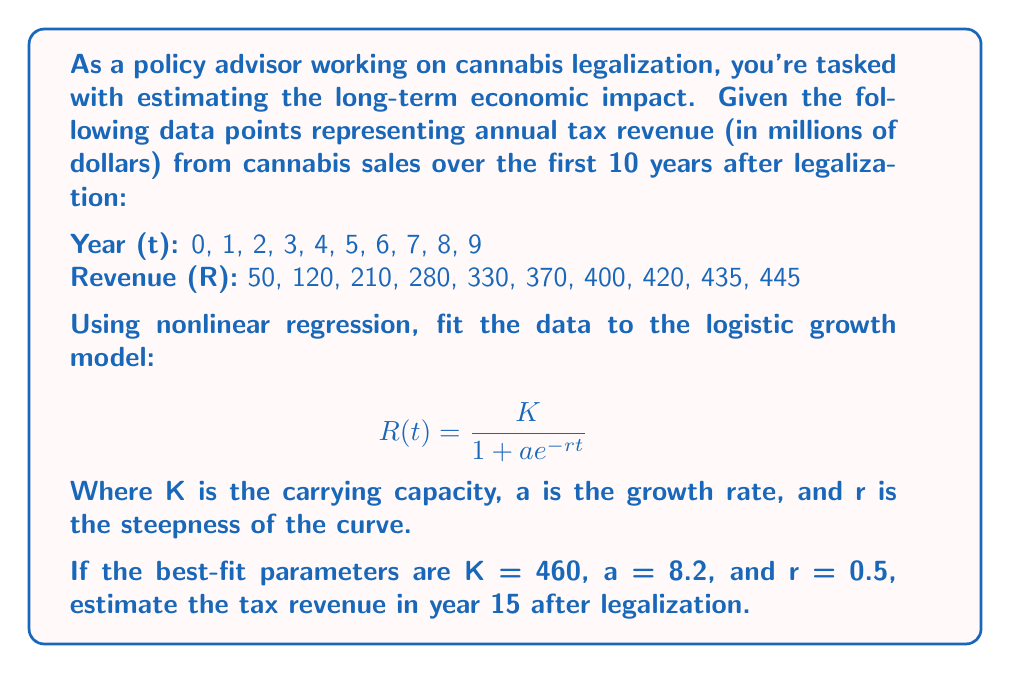Solve this math problem. To solve this problem, we'll follow these steps:

1) We're given the logistic growth model:
   $$ R(t) = \frac{K}{1 + ae^{-rt}} $$

2) We're also given the best-fit parameters:
   K = 460 (carrying capacity)
   a = 8.2 (growth rate)
   r = 0.5 (steepness of the curve)

3) To estimate the tax revenue in year 15, we need to substitute t = 15 and these parameters into the equation:

   $$ R(15) = \frac{460}{1 + 8.2e^{-0.5(15)}} $$

4) Let's solve this step by step:
   a) First, calculate the exponent: -0.5(15) = -7.5
   b) Then, calculate $e^{-7.5}$:
      $e^{-7.5} \approx 0.00055$
   c) Multiply this by 8.2:
      $8.2 * 0.00055 \approx 0.00451$
   d) Add 1 to this result:
      $1 + 0.00451 = 1.00451$
   e) Finally, divide 460 by this number:
      $\frac{460}{1.00451} \approx 457.93$

5) Therefore, the estimated tax revenue in year 15 after legalization is approximately $457.93 million.

This result makes sense in the context of the logistic growth model, as it's approaching but not quite reaching the carrying capacity of $460 million.
Answer: $457.93 million 